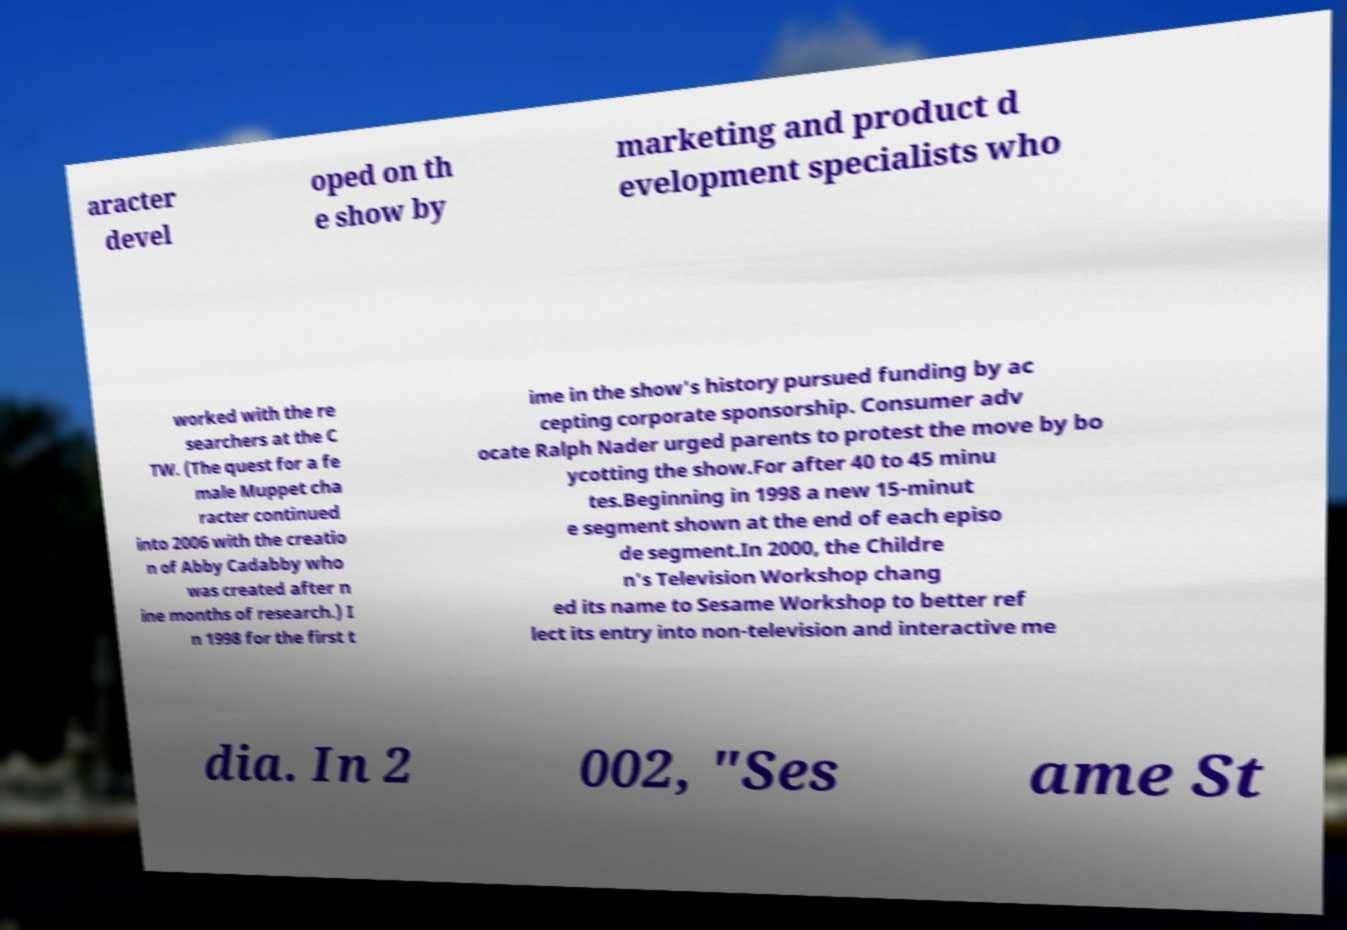What messages or text are displayed in this image? I need them in a readable, typed format. aracter devel oped on th e show by marketing and product d evelopment specialists who worked with the re searchers at the C TW. (The quest for a fe male Muppet cha racter continued into 2006 with the creatio n of Abby Cadabby who was created after n ine months of research.) I n 1998 for the first t ime in the show's history pursued funding by ac cepting corporate sponsorship. Consumer adv ocate Ralph Nader urged parents to protest the move by bo ycotting the show.For after 40 to 45 minu tes.Beginning in 1998 a new 15-minut e segment shown at the end of each episo de segment.In 2000, the Childre n's Television Workshop chang ed its name to Sesame Workshop to better ref lect its entry into non-television and interactive me dia. In 2 002, "Ses ame St 